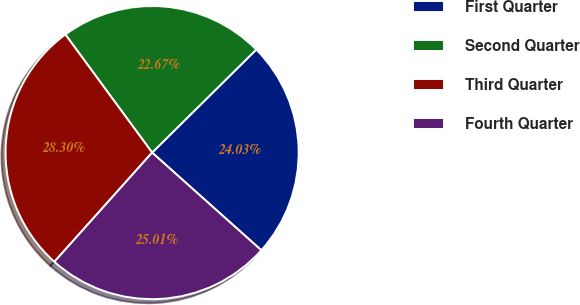<chart> <loc_0><loc_0><loc_500><loc_500><pie_chart><fcel>First Quarter<fcel>Second Quarter<fcel>Third Quarter<fcel>Fourth Quarter<nl><fcel>24.03%<fcel>22.67%<fcel>28.3%<fcel>25.01%<nl></chart> 